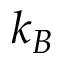<formula> <loc_0><loc_0><loc_500><loc_500>k _ { B }</formula> 